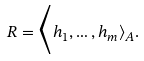Convert formula to latex. <formula><loc_0><loc_0><loc_500><loc_500>R = \Big \langle h _ { 1 } , \dots , h _ { m } \rangle _ { A } .</formula> 